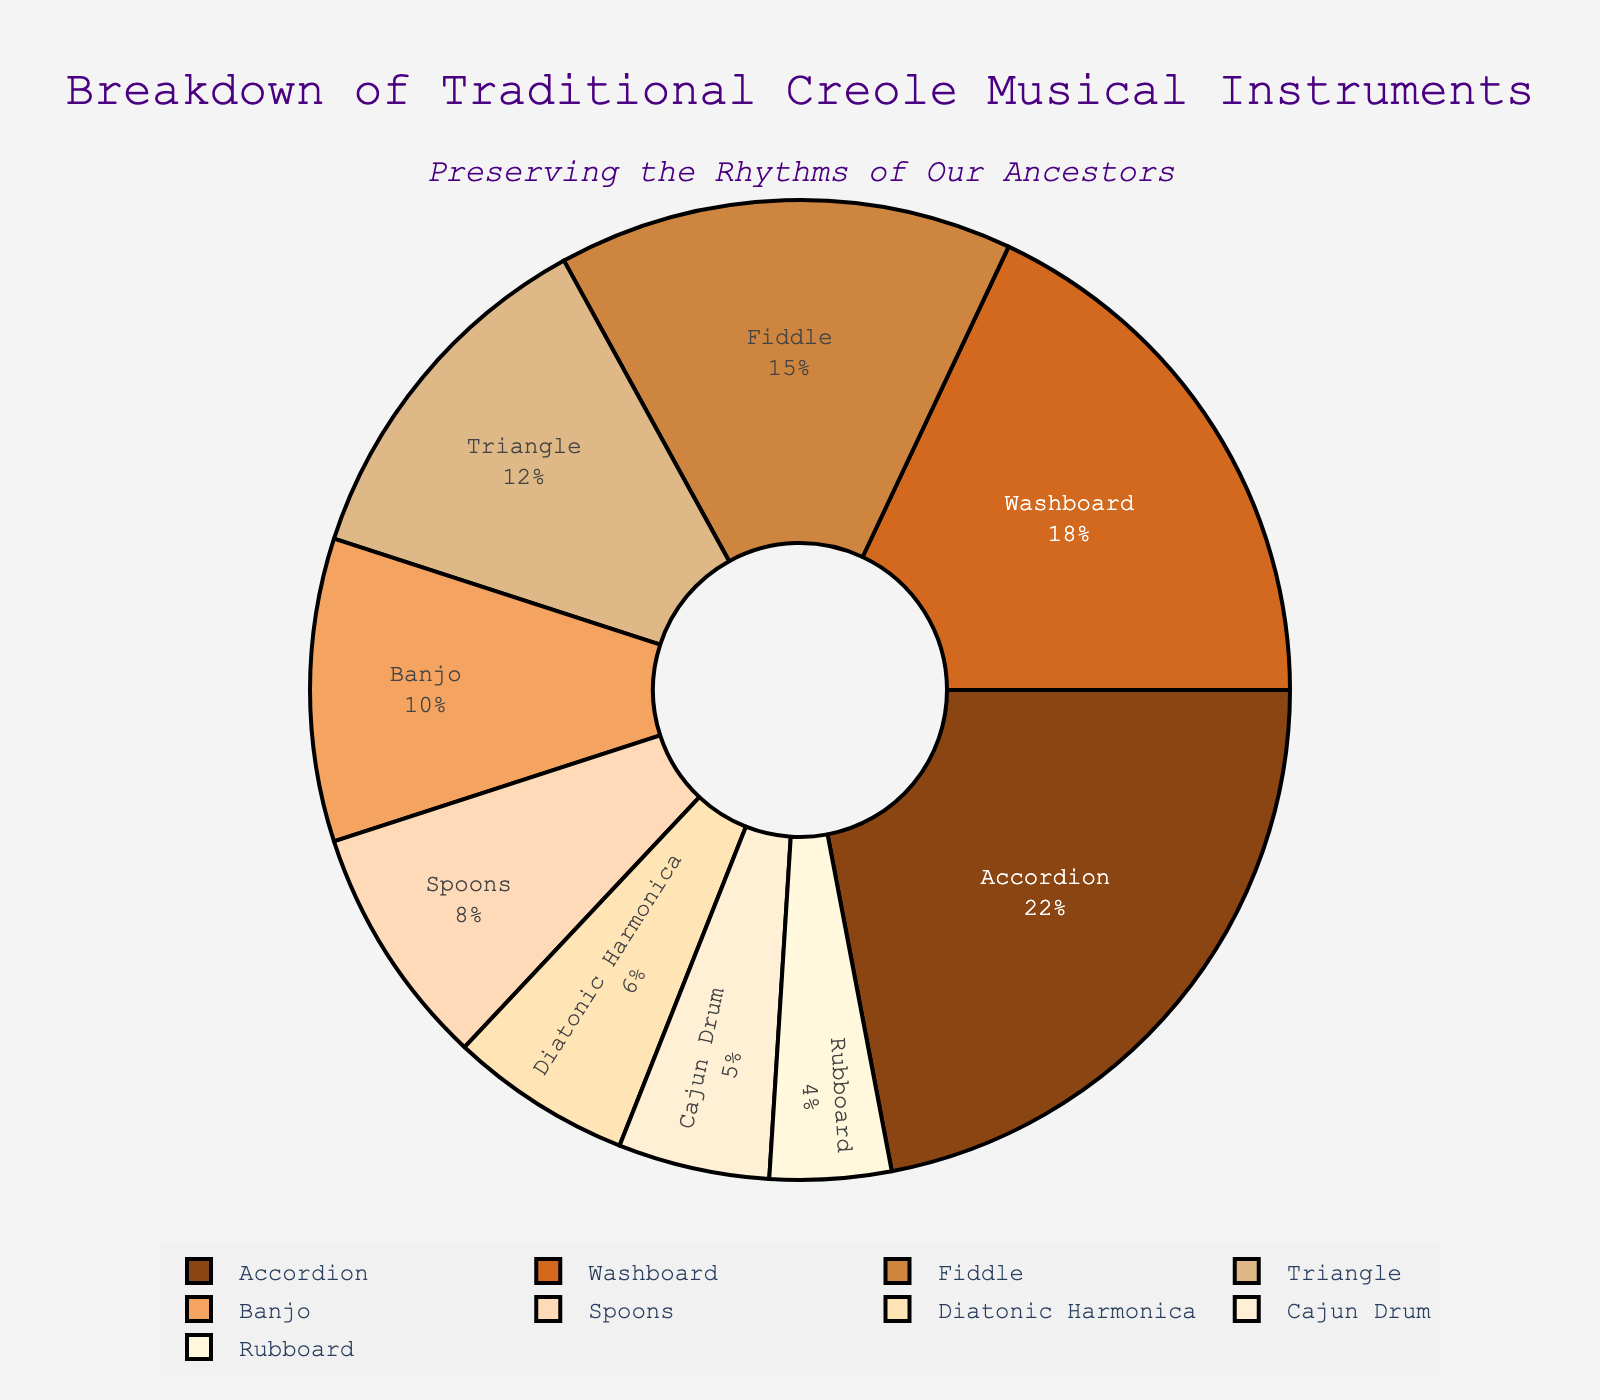What percentage of the instruments are classified as having more than 10% usage? Identify instruments with a percentage greater than 10%. Those are: Accordion (22%), Washboard (18%), Fiddle (15%), and Triangle (12%). Now, count them (4) and calculate their combined percentage 22% + 18% + 15% + 12% = 67%. Thus, 4 instruments have more than 10% usage.
Answer: 67% Which instrument has the highest percentage? Look for the instrument with the highest numerical value in the 'Percentage' column. Accordion has 22%, which is the highest among all.
Answer: Accordion What is the combined percentage of the Rubboard and Cajun Drum? Add the percentages of Rubboard and Cajun Drum. Rubboard has 4% and Cajun Drum has 5%. So, 4% + 5% = 9%.
Answer: 9% How does the percentage of the Triangle compare to that of the Banjo? Compare the percentages of the Triangle and Banjo. Triangle has 12%, while Banjo has 10%. 12% > 10%, so the Triangle's percentage is higher.
Answer: Triangle's percentage is higher Which instrument has the smallest percentage? Find the instrument with the lowest numerical value in the 'Percentage' column. The Rubboard has the smallest percentage at 4%.
Answer: Rubboard Sum the percentages of instruments that are used the least (less than 10%) Identify and sum up the percentages of Spoons, Diatonic Harmonica, Cajun Drum, and Rubboard. That’s 8% + 6% + 5% + 4% = 23%.
Answer: 23% What percentage of instruments are between 5% and 15%? Identify instruments between 5% and 15%. These are Fiddle (15%), Triangle (12%), Banjo (10%), Spoons (8%), Diatonic Harmonica (6%), and Cajun Drum (5%). Sum these: 15% + 12% + 10% + 8% + 6% + 5% = 56%.
Answer: 56% Which instrument percentages are summed up to form the majority (more than 50%)? Start from the highest and sum until the total exceeds 50%. Accordion (22%) + Washboard (18%) + Fiddle (15%) = 55%, which is already above 50%.
Answer: Accordion, Washboard, Fiddle What is the mean percentage of usage for all instruments? Add up all percentages and divide by the number of instruments. The total sum is 100%. There are 9 instruments. 100% / 9 ≈ 11.11%.
Answer: 11.11% What is the mean percentage difference between the highest and the lowest used instruments? Calculate the difference between the highest (Accordion 22%) and the lowest (Rubboard 4%) and divide by 2. (22% - 4%) / 2 = 18% / 2 = 9%.
Answer: 9% 